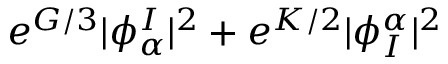Convert formula to latex. <formula><loc_0><loc_0><loc_500><loc_500>e ^ { G / 3 } | \phi _ { \alpha } ^ { I } | ^ { 2 } + e ^ { K / 2 } | \phi _ { I } ^ { \alpha } | ^ { 2 }</formula> 